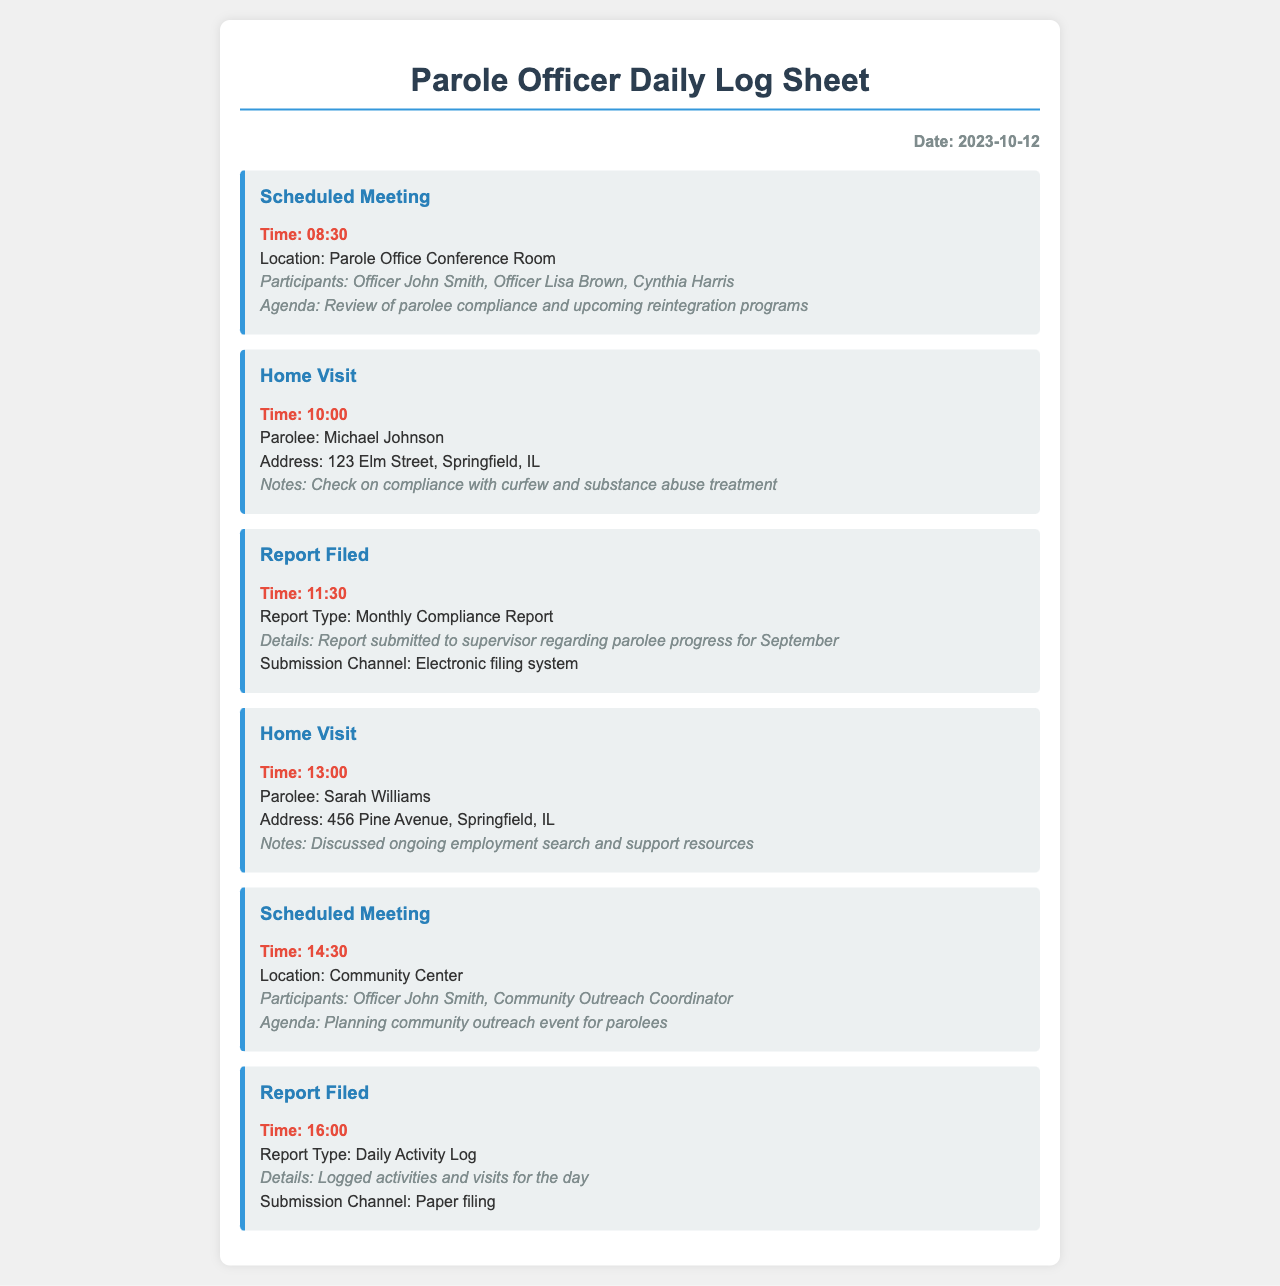what date is the log sheet for? The log sheet is dated October 12, 2023.
Answer: October 12, 2023 what time was the first scheduled meeting? The first scheduled meeting is at 08:30.
Answer: 08:30 who were the participants in the home visit with Michael Johnson? The home visit with Michael Johnson does not list participants, just the parolee and notes.
Answer: Michael Johnson what was the agenda for the scheduled meeting at the Parole Office? The agenda involves reviewing parolee compliance and reintegration programs.
Answer: Review of parolee compliance and upcoming reintegration programs how many reports were filed on this day? There are two reports filed during this day.
Answer: 2 at what time was the report for monthly compliance submitted? The report for monthly compliance was submitted at 11:30.
Answer: 11:30 what was discussed during the home visit with Sarah Williams? The visit included discussion on employment search and support resources.
Answer: Ongoing employment search and support resources what location was the second scheduled meeting held? The second scheduled meeting was at the Community Center.
Answer: Community Center what type of report was filed at 16:00? The report filed at 16:00 is a Daily Activity Log.
Answer: Daily Activity Log 